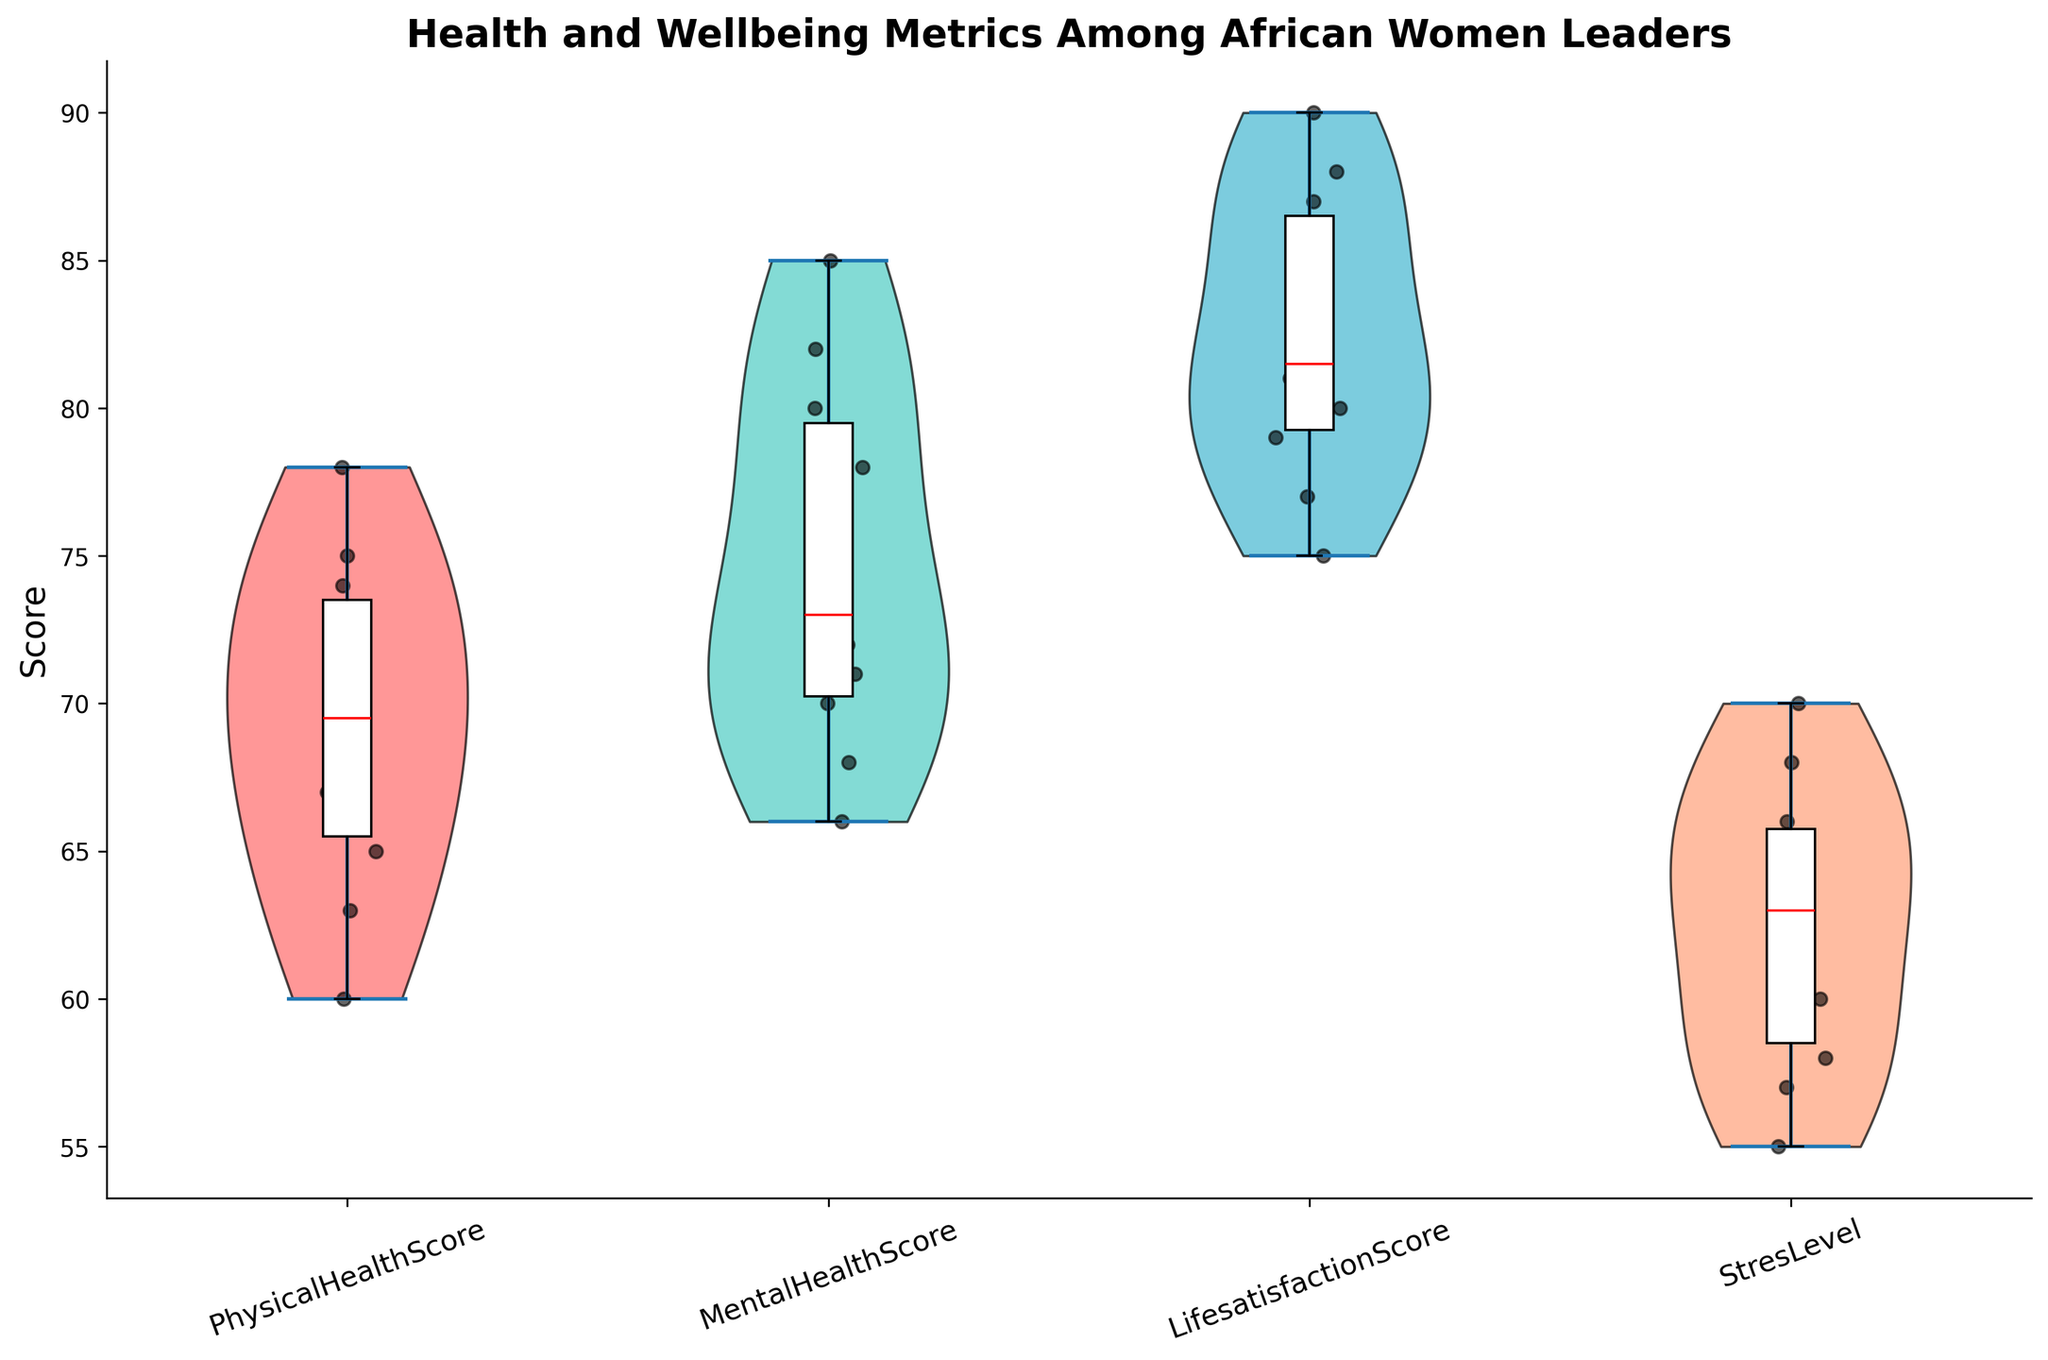What is the title of the figure? The title of the figure is typically shown at the top. In this case, it should be visible and written in a large font for emphasis.
Answer: Health and Wellbeing Metrics Among African Women Leaders What does the y-axis represent? The y-axis usually represents the variable being measured. In this case, it displays the scores of various health and wellbeing metrics.
Answer: Score Which metric appears to have the highest median score? To determine the median value, look at the red line within each box plot. Compare the positions of the red lines across the different metrics.
Answer: LifesatisfactionScore How many metrics are displayed on the x-axis? The x-axis labels show the different metrics. Counting the labels will give the number of metrics displayed.
Answer: Four What is the range of the PhysicalHealthScore as shown by the violin plot? The range is represented by the width of the violin plot. Examine the spread of the plot for the PhysicalHealthScore along the y-axis.
Answer: 60 to 78 Which metric has the smallest interquartile range (IQR)? The IQR can be determined by the height of the box in the box plot. Compare the heights of the boxes for each metric.
Answer: MentalHealthScore Compare the mean PhysicalHealthScore and MentalHealthScore. Which one is higher? Means are shown by the central horizontal lines within the violins. Compare the centers of the violins for PhysicalHealthScore and MentalHealthScore.
Answer: MentalHealthScore Which country's leader has the highest PhysicalHealthScore? In the scatter plot, each dot represents a data point. Locate the highest dot in the PhysicalHealthScore plot and identify its corresponding country.
Answer: Kenya Are the stress levels generally high or low compared to other metrics? Compare the overall heights and spreads of the violins for stress levels to the others. Lower and narrower violins indicate lower values.
Answer: Generally high What can be inferred about the variation in LifesatisfactionScore? The width and height of the violin plot indicate variation. A violin plot that is both tall and wide shows high variation.
Answer: High variation 